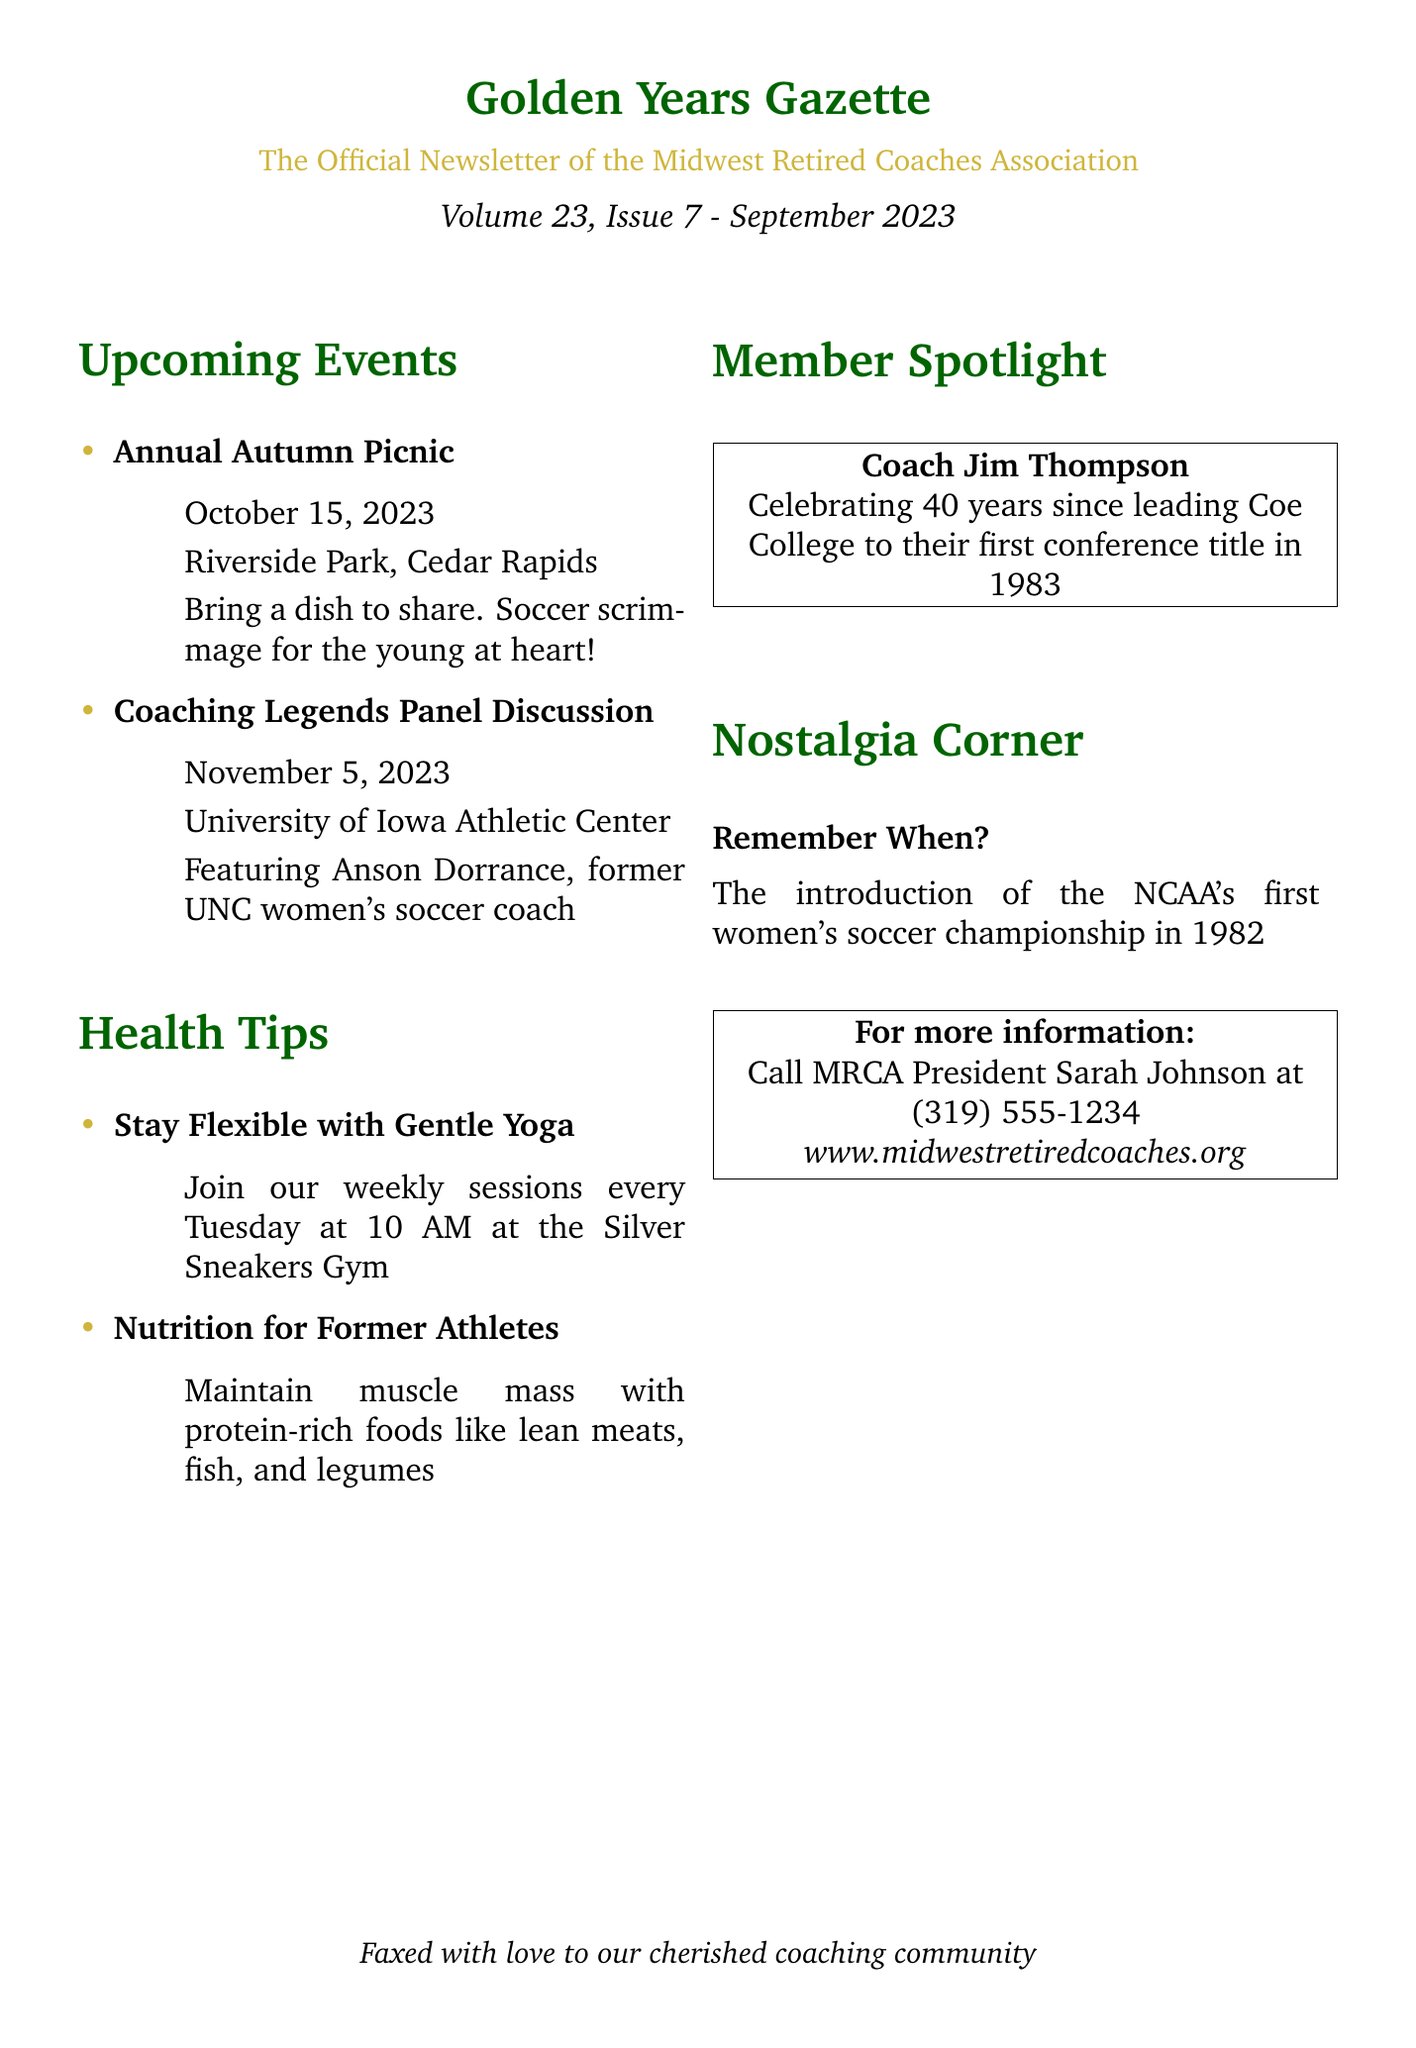What is the title of the newsletter? The title is prominently displayed at the top of the document.
Answer: Golden Years Gazette When is the Annual Autumn Picnic? The date of the event is mentioned in the upcoming events section.
Answer: October 15, 2023 Where will the Coaching Legends Panel Discussion be held? The location of the event is specified in the document.
Answer: University of Iowa Athletic Center Who is featured in the Coaching Legends Panel Discussion? The name of the featured coach is highlighted within the event details.
Answer: Anson Dorrance What is one of the health tips provided? The health tip is listed in the health tips section of the document.
Answer: Stay Flexible with Gentle Yoga What day and time are the yoga sessions? Details about the yoga sessions include the day and time provided in the health tips section.
Answer: Every Tuesday at 10 AM Whose anniversary is being celebrated in the Member Spotlight? The person being recognized is specified in the spotlight section.
Answer: Coach Jim Thompson What year did Coach Jim Thompson lead Coe College to their first conference title? The document provides the year relevant to the member spotlight.
Answer: 1983 What historical event is mentioned in the Nostalgia Corner? The nostalgic event is noted specifically in the boxes section.
Answer: The introduction of the NCAA's first women's soccer championship in 1982 